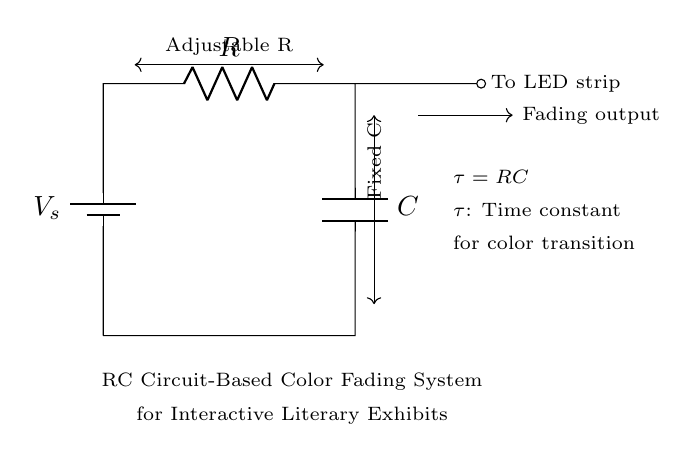What components are in the circuit? The circuit contains a battery, a resistor, and a capacitor, which are common components used to create an RC circuit.
Answer: battery, resistor, capacitor What is the function of the capacitor in this circuit? The capacitor stores electrical energy and releases it over time, affecting the color fading effect of the LED strip in the exhibit.
Answer: store energy What does the symbol 'V_s' represent? 'V_s' represents the power source voltage, which is the supply voltage for the circuit.
Answer: power source voltage What is the role of the adjustable resistor? The adjustable resistor allows modification of the resistance value, thereby altering the time constant and control over the fading rate of the LED colors.
Answer: control fading rate What is the time constant formula given in the circuit? The time constant formula is represented as tau equals RC, where R is resistance in ohms and C is capacitance in farads.
Answer: tau equals RC If the resistance is increased, what happens to the fading speed of the LED strip? If resistance increases, the time constant also increases, which means the LED strip fades more slowly due to slower charging and discharging of the capacitor.
Answer: fades more slowly What is meant by the term 'fading output'? 'Fading output' refers to the variable intensity of light emitted by the LED strip as it gradually changes color through the charging and discharging cycle of the capacitor.
Answer: variable light intensity 